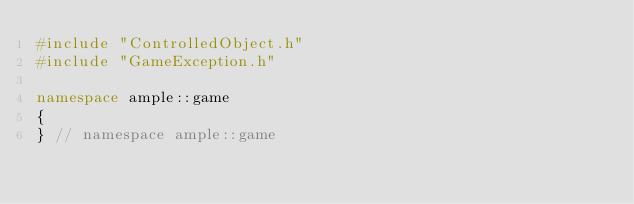<code> <loc_0><loc_0><loc_500><loc_500><_C++_>#include "ControlledObject.h"
#include "GameException.h"

namespace ample::game
{
} // namespace ample::game
</code> 